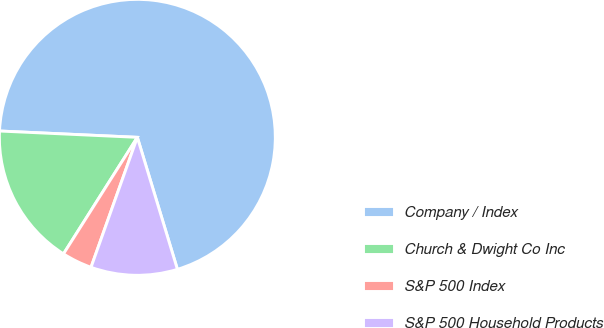Convert chart to OTSL. <chart><loc_0><loc_0><loc_500><loc_500><pie_chart><fcel>Company / Index<fcel>Church & Dwight Co Inc<fcel>S&P 500 Index<fcel>S&P 500 Household Products<nl><fcel>69.58%<fcel>16.74%<fcel>3.54%<fcel>10.14%<nl></chart> 